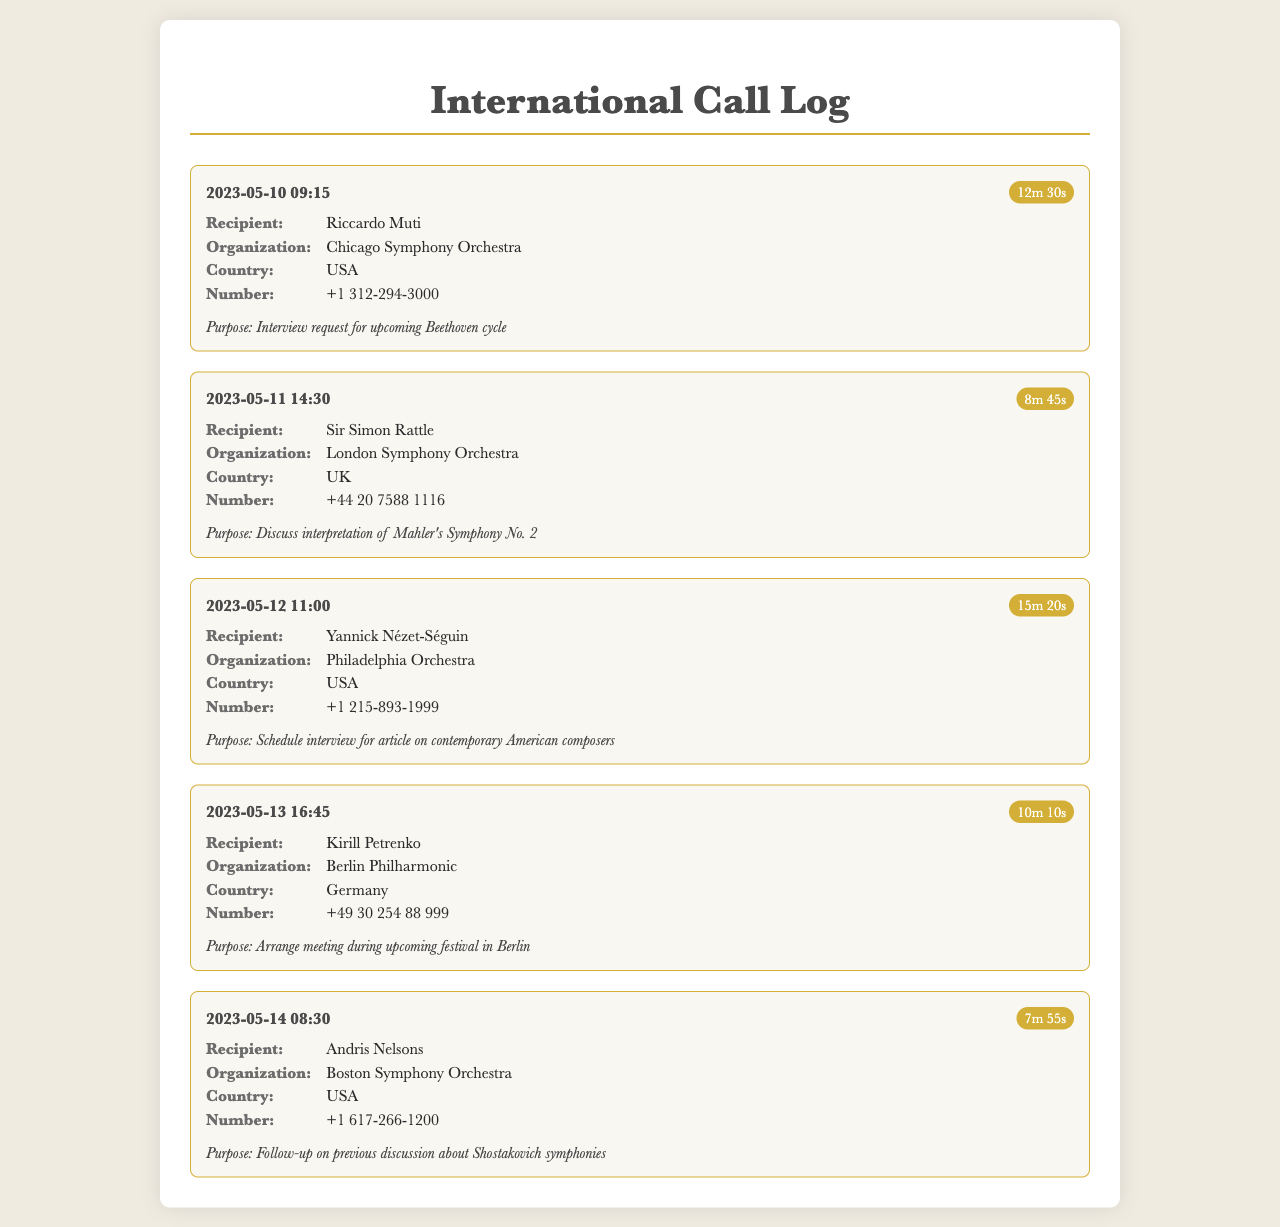what is the date of the call to Riccardo Muti? The date of the call is listed in the log entry for Riccardo Muti.
Answer: 2023-05-10 who is the recipient of the call on May 11? The recipient for the call on May 11 can be found in the corresponding entry.
Answer: Sir Simon Rattle how long was the call with Yannick Nézet-Séguin? The duration of the call is mentioned in the call details for Yannick Nézet-Séguin.
Answer: 15m 20s what is the primary purpose of the call to Kirill Petrenko? The purpose of the call to Kirill Petrenko is specified in the call entry for his discussion.
Answer: Arrange meeting during upcoming festival in Berlin what country is associated with the Boston Symphony Orchestra? The country for the Boston Symphony Orchestra is indicated in the entry for Andris Nelsons.
Answer: USA which conductor has a call related to Mahler's Symphony No. 2? The call related to Mahler's Symphony No. 2 can be found in the details for a specific recipient.
Answer: Sir Simon Rattle what is the organization of the recipient called on May 13? The organization associated with the recipient on May 13 is addressed in the call details.
Answer: Berlin Philharmonic what is the phone number for the Chicago Symphony Orchestra? The phone number for the Chicago Symphony Orchestra is listed under the call details for Riccardo Muti.
Answer: +1 312-294-3000 